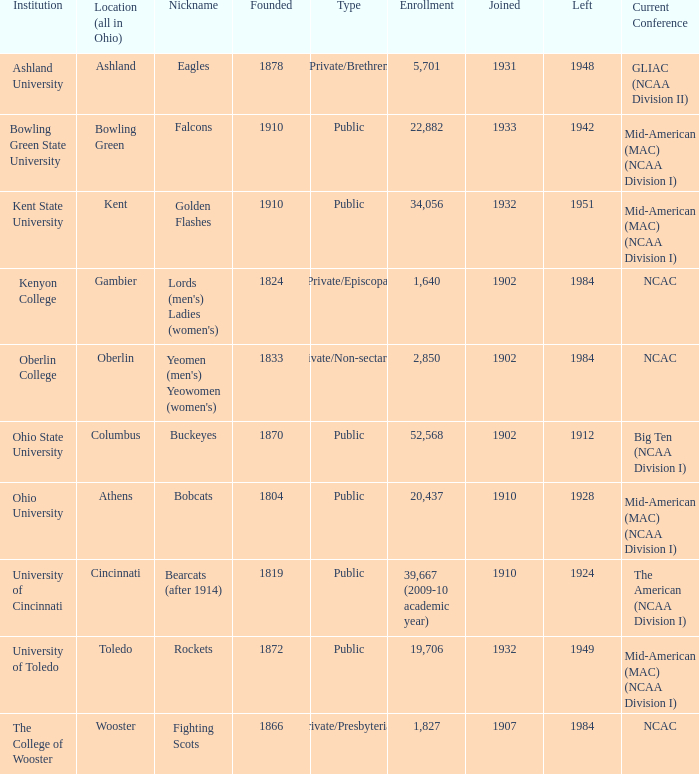Which founding year corresponds with the highest enrollment?  1910.0. 